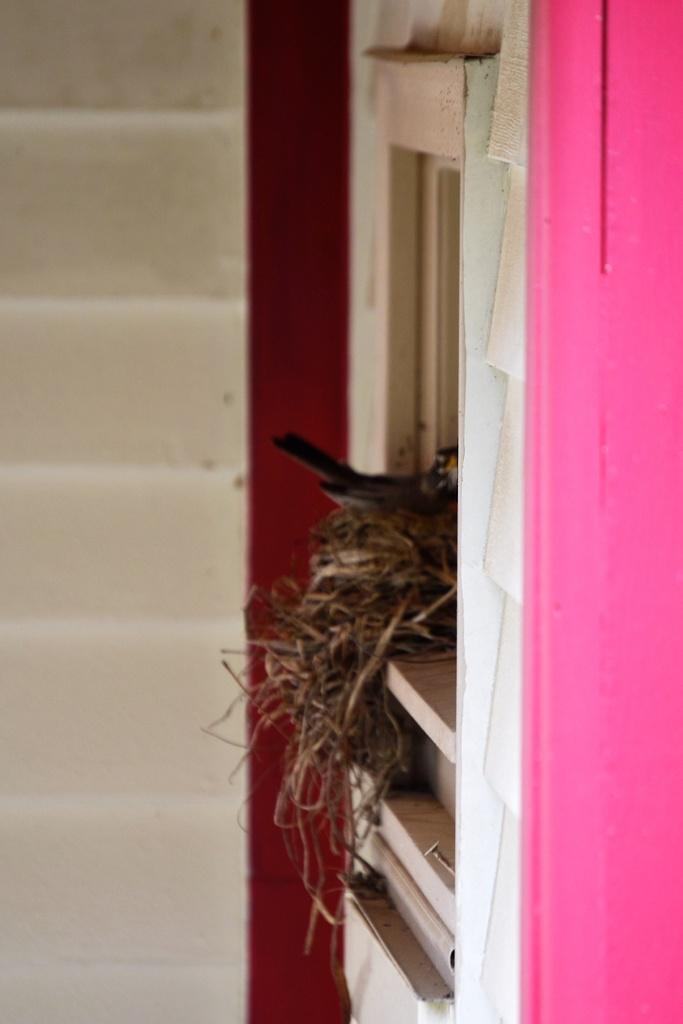What is located in the nest in the image? There is a bird in a nest in the image. Where is the nest situated? The nest is on a window. What color is the wall on the right side of the image? The wall on the right side of the image is painted pink. What type of sheet is covering the bird in the image? There is no sheet covering the bird in the image; it is in a nest on a window. 